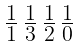<formula> <loc_0><loc_0><loc_500><loc_500>\begin{smallmatrix} 1 & 1 & 1 & 1 \\ \overline { 1 } & \overline { 3 } & \overline { 2 } & \overline { 0 } \end{smallmatrix}</formula> 